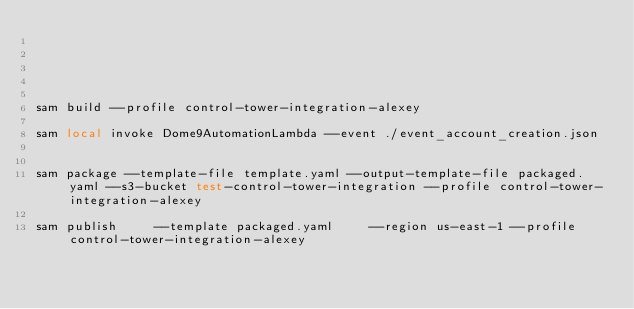Convert code to text. <code><loc_0><loc_0><loc_500><loc_500><_Bash_>




sam build --profile control-tower-integration-alexey

sam local invoke Dome9AutomationLambda --event ./event_account_creation.json


sam package --template-file template.yaml --output-template-file packaged.yaml --s3-bucket test-control-tower-integration --profile control-tower-integration-alexey

sam publish     --template packaged.yaml     --region us-east-1 --profile control-tower-integration-alexey













</code> 